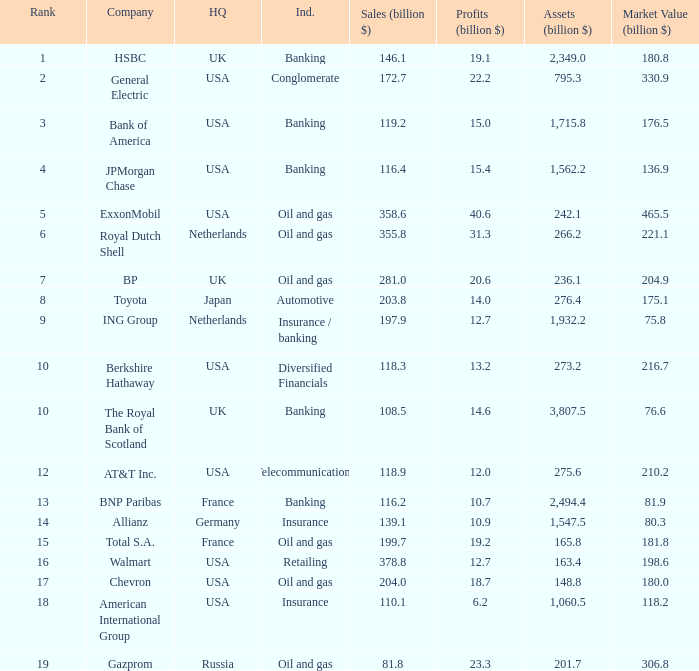Which industry has a company with a market value of 80.3 billion?  Insurance. 